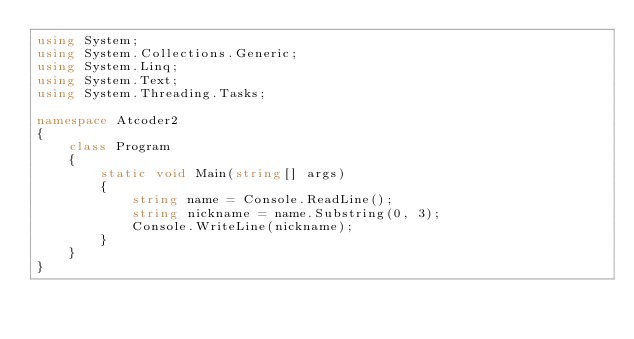<code> <loc_0><loc_0><loc_500><loc_500><_C#_>using System;
using System.Collections.Generic;
using System.Linq;
using System.Text;
using System.Threading.Tasks;

namespace Atcoder2
{
    class Program
    {
        static void Main(string[] args)
        {
            string name = Console.ReadLine();
            string nickname = name.Substring(0, 3);
            Console.WriteLine(nickname);
        }
    }
}</code> 